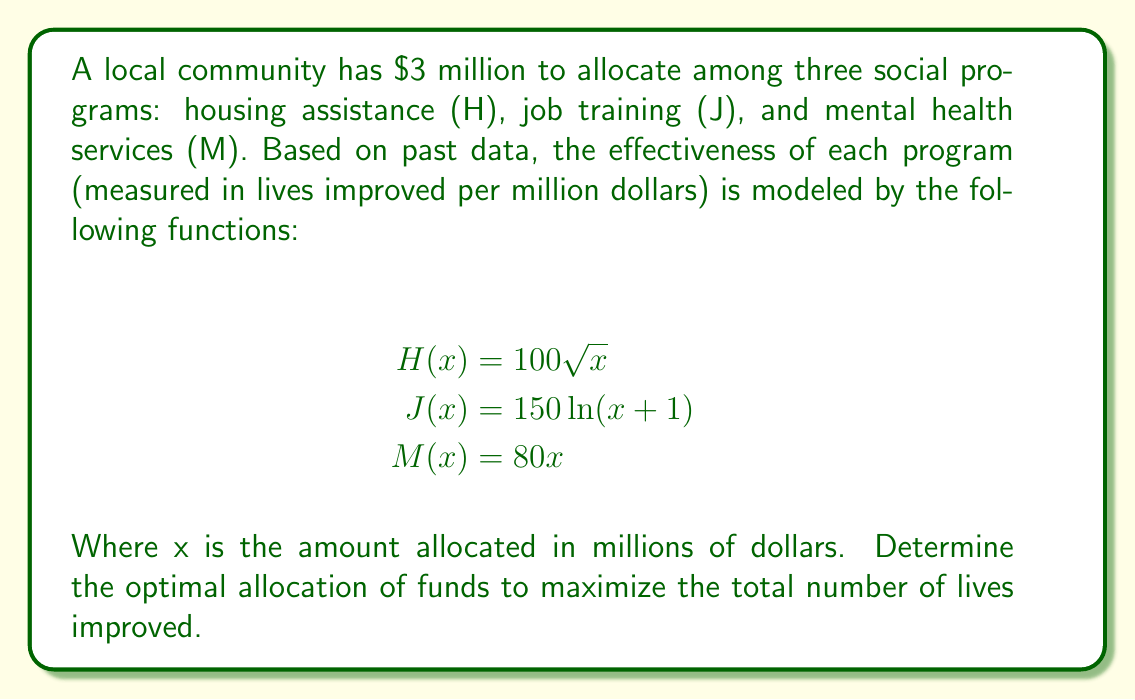Show me your answer to this math problem. To solve this optimization problem, we'll use the method of Lagrange multipliers:

1) Let the allocation to each program be $x$, $y$, and $z$ respectively. Our objective function is:

   $$f(x,y,z) = 100\sqrt{x} + 150\ln(y+1) + 80z$$

2) Our constraint is:

   $$g(x,y,z) = x + y + z - 3 = 0$$

3) We form the Lagrangian:

   $$L(x,y,z,\lambda) = 100\sqrt{x} + 150\ln(y+1) + 80z - \lambda(x + y + z - 3)$$

4) We set partial derivatives to zero:

   $$\frac{\partial L}{\partial x} = \frac{50}{\sqrt{x}} - \lambda = 0$$
   $$\frac{\partial L}{\partial y} = \frac{150}{y+1} - \lambda = 0$$
   $$\frac{\partial L}{\partial z} = 80 - \lambda = 0$$
   $$\frac{\partial L}{\partial \lambda} = x + y + z - 3 = 0$$

5) From the third equation, we get $\lambda = 80$. Substituting this into the first two equations:

   $$\frac{50}{\sqrt{x}} = 80 \implies x = \frac{25}{64} \approx 0.39$$
   $$\frac{150}{y+1} = 80 \implies y = \frac{15}{8} - 1 = \frac{7}{8} \approx 0.875$$

6) Using the constraint equation:

   $$z = 3 - x - y = 3 - \frac{25}{64} - \frac{7}{8} = \frac{111}{64} \approx 1.734$$

7) Therefore, the optimal allocation is approximately:
   Housing: $0.39 million
   Job training: $0.875 million
   Mental health: $1.734 million
Answer: H: $0.39M, J: $0.875M, M: $1.734M 